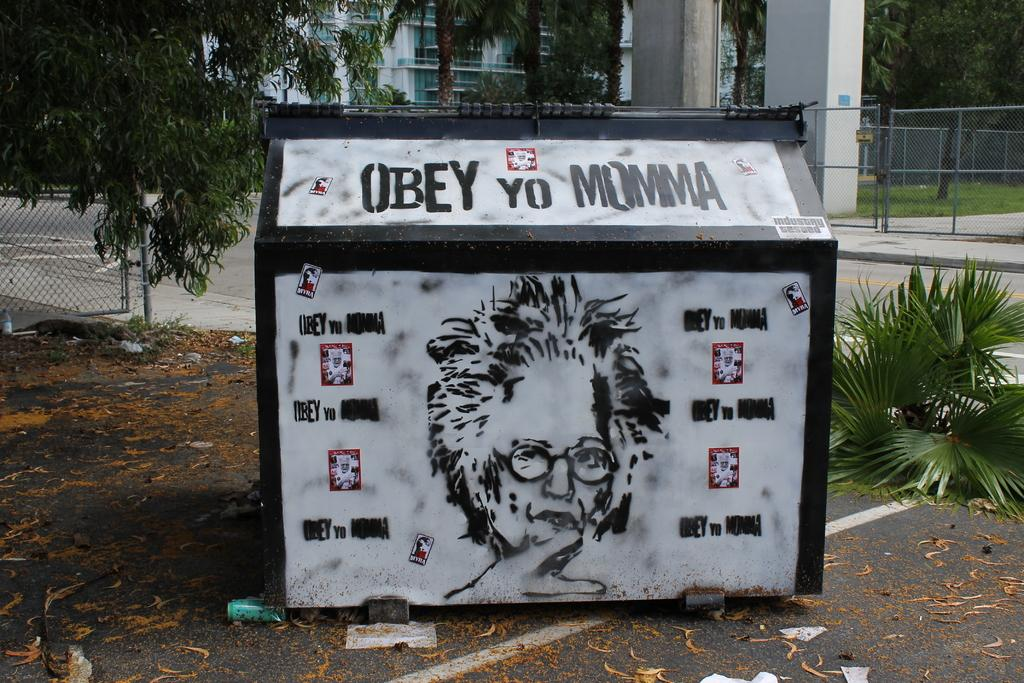What is the main structure in the center of the image? There is a cabin in the center of the image. What can be seen in the background of the image? There are trees, buildings, a fence, and a road in the background of the image. How does the business in the image care for the increase in customers? There is no business or customers mentioned in the image; it features a cabin and background elements. 